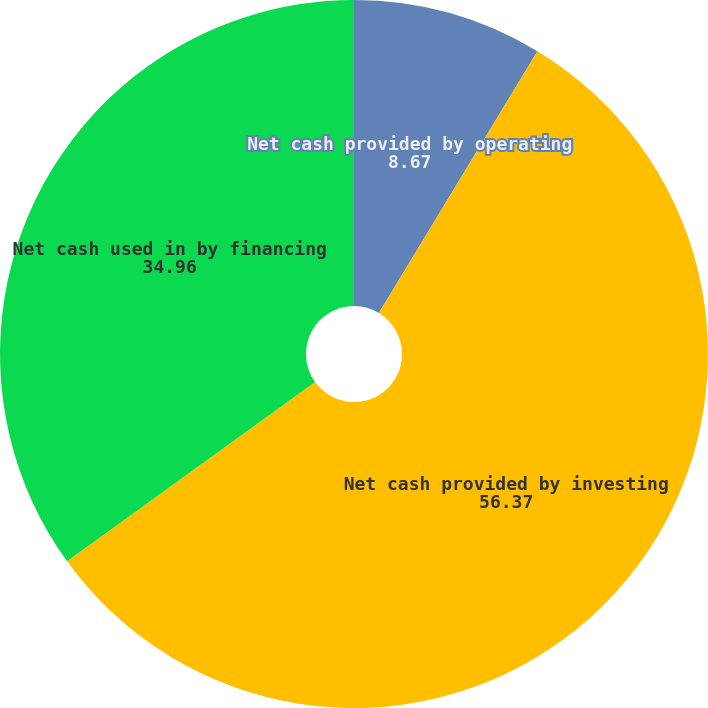Convert chart to OTSL. <chart><loc_0><loc_0><loc_500><loc_500><pie_chart><fcel>Net cash provided by operating<fcel>Net cash provided by investing<fcel>Net cash used in by financing<nl><fcel>8.67%<fcel>56.37%<fcel>34.96%<nl></chart> 